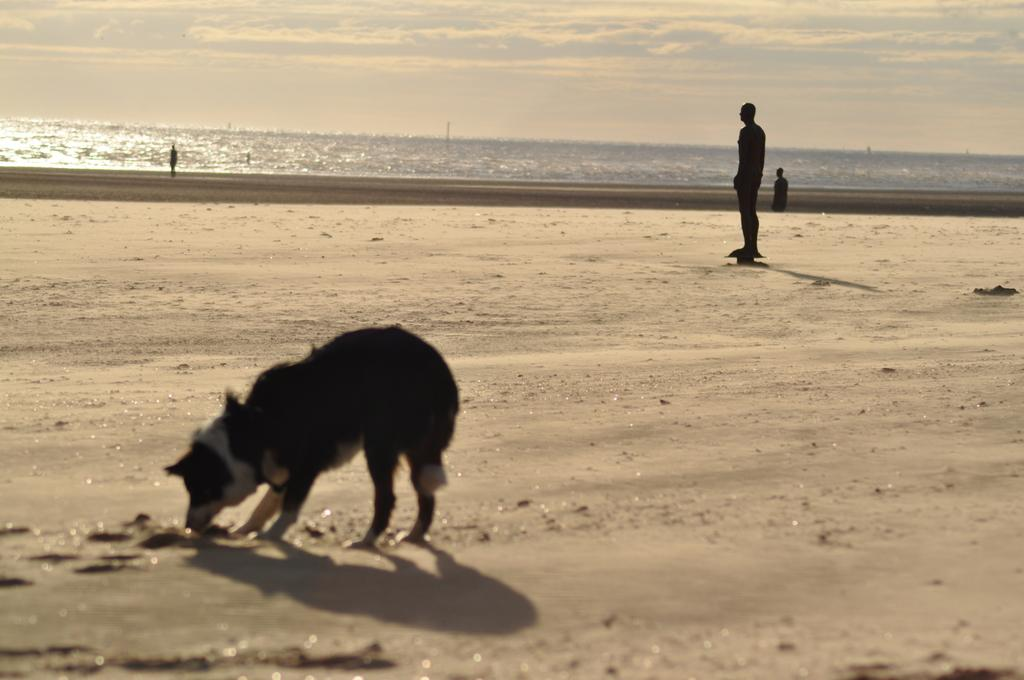What type of surface is visible in the image? There is ground visible in the image. What animal can be seen in the image? There is a dog in the image. What are the people in the image doing? There are people standing on the ground in the image. What can be seen in the distance in the image? There is water visible in the background of the image. What else is visible in the background of the image? The sky is visible in the background of the image. What grade did the daughter receive on her recent test in the image? There is no mention of a daughter or a test in the image, so it is not possible to answer that question. 